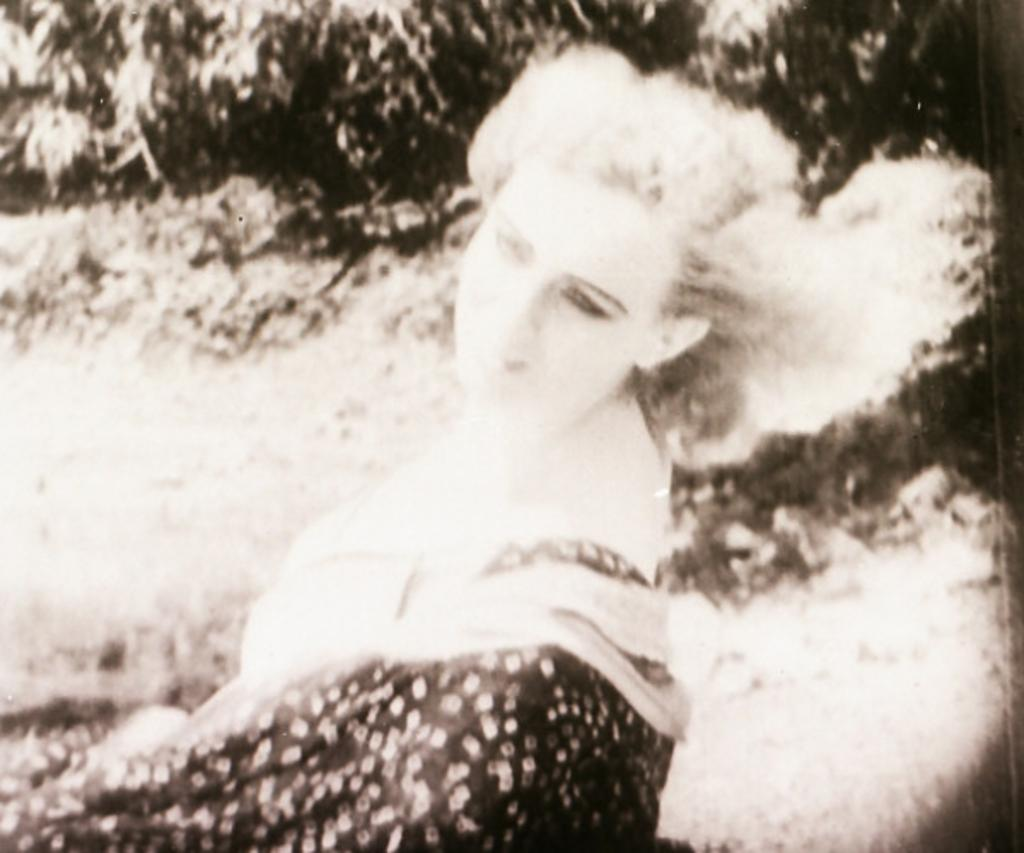What is the color scheme of the image? The image is black and white. Who or what is the main subject in the image? There is a woman in the image. What can be seen in the background of the image? There are trees and plants in the background of the image. Can you tell me how many bees are buzzing around the woman in the image? There are no bees present in the image; it is a black and white image featuring a woman and a background with trees and plants. 